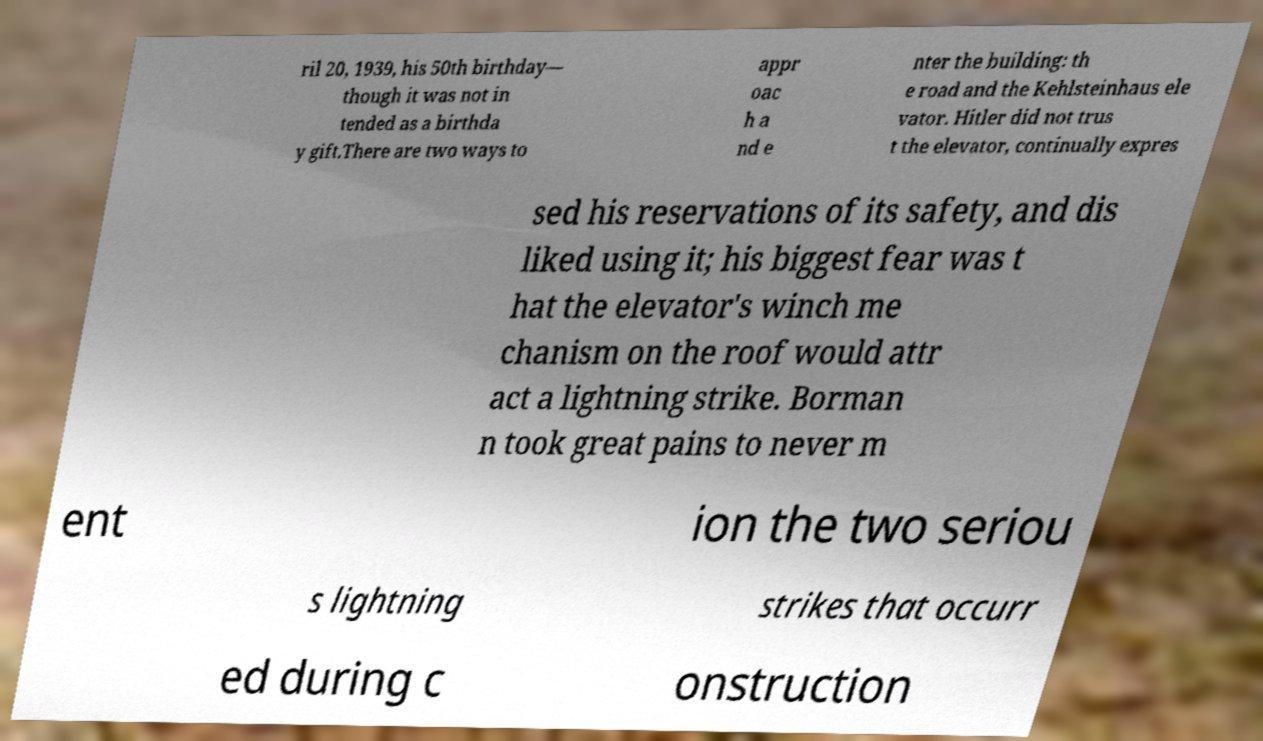For documentation purposes, I need the text within this image transcribed. Could you provide that? ril 20, 1939, his 50th birthday— though it was not in tended as a birthda y gift.There are two ways to appr oac h a nd e nter the building: th e road and the Kehlsteinhaus ele vator. Hitler did not trus t the elevator, continually expres sed his reservations of its safety, and dis liked using it; his biggest fear was t hat the elevator's winch me chanism on the roof would attr act a lightning strike. Borman n took great pains to never m ent ion the two seriou s lightning strikes that occurr ed during c onstruction 